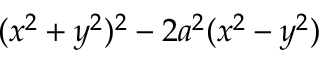Convert formula to latex. <formula><loc_0><loc_0><loc_500><loc_500>( x ^ { 2 } + y ^ { 2 } ) ^ { 2 } - 2 a ^ { 2 } ( x ^ { 2 } - y ^ { 2 } )</formula> 